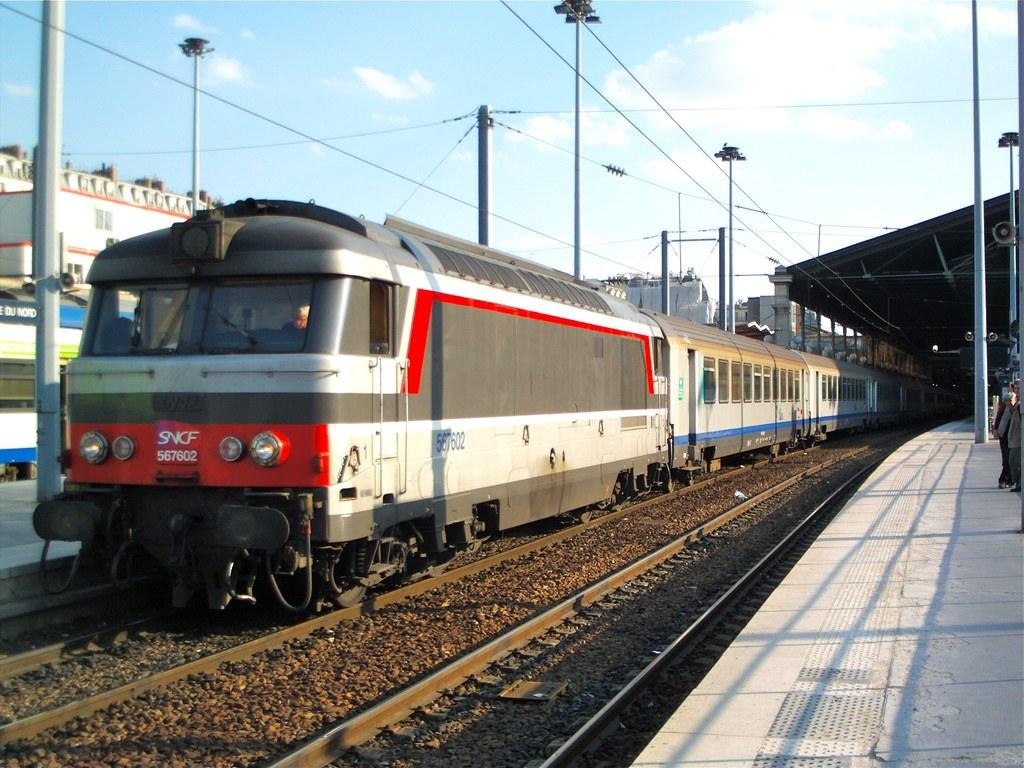What is the main subject of the image? The main subject of the image is a train. Where is the train located in the image? The train is on a railway track. What else can be seen in the image besides the train? There are poles, buildings, people standing on a platform, and the sky visible in the background. What is the condition of the sky in the image? The sky is visible in the background of the image, and clouds are present. How does the dirt affect the train's movement in the image? There is no dirt present in the image, so it does not affect the train's movement. What type of comb can be seen in the hands of the people on the platform? There is no comb present in the image; the people on the platform are not holding any objects. 